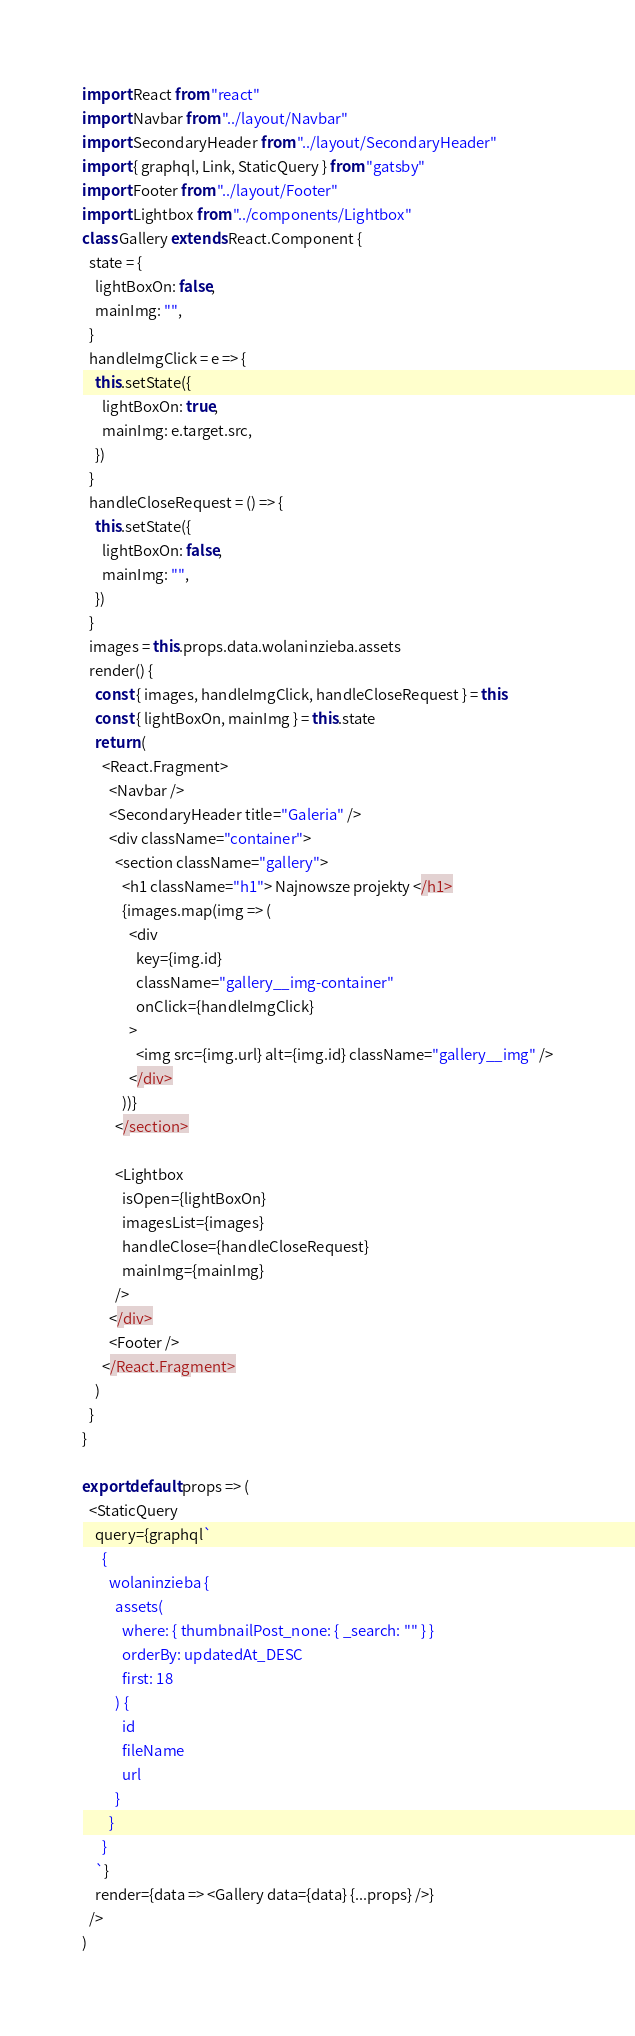Convert code to text. <code><loc_0><loc_0><loc_500><loc_500><_JavaScript_>import React from "react"
import Navbar from "../layout/Navbar"
import SecondaryHeader from "../layout/SecondaryHeader"
import { graphql, Link, StaticQuery } from "gatsby"
import Footer from "../layout/Footer"
import Lightbox from "../components/Lightbox"
class Gallery extends React.Component {
  state = {
    lightBoxOn: false,
    mainImg: "",
  }
  handleImgClick = e => {
    this.setState({
      lightBoxOn: true,
      mainImg: e.target.src,
    })
  }
  handleCloseRequest = () => {
    this.setState({
      lightBoxOn: false,
      mainImg: "",
    })
  }
  images = this.props.data.wolaninzieba.assets
  render() {
    const { images, handleImgClick, handleCloseRequest } = this
    const { lightBoxOn, mainImg } = this.state
    return (
      <React.Fragment>
        <Navbar />
        <SecondaryHeader title="Galeria" />
        <div className="container">
          <section className="gallery">
            <h1 className="h1"> Najnowsze projekty </h1>
            {images.map(img => (
              <div
                key={img.id}
                className="gallery__img-container"
                onClick={handleImgClick}
              >
                <img src={img.url} alt={img.id} className="gallery__img" />
              </div>
            ))}
          </section>

          <Lightbox
            isOpen={lightBoxOn}
            imagesList={images}
            handleClose={handleCloseRequest}
            mainImg={mainImg}
          />
        </div>
        <Footer />
      </React.Fragment>
    )
  }
}

export default props => (
  <StaticQuery
    query={graphql`
      {
        wolaninzieba {
          assets(
            where: { thumbnailPost_none: { _search: "" } }
            orderBy: updatedAt_DESC
            first: 18
          ) {
            id
            fileName
            url
          }
        }
      }
    `}
    render={data => <Gallery data={data} {...props} />}
  />
)
</code> 